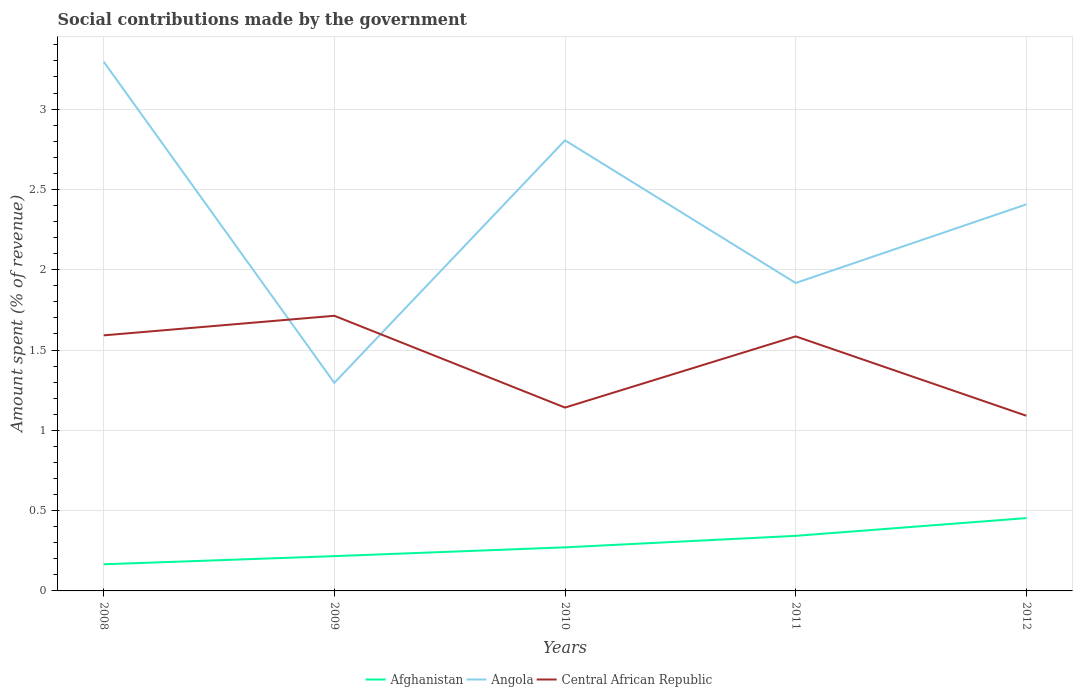How many different coloured lines are there?
Offer a very short reply. 3. Does the line corresponding to Central African Republic intersect with the line corresponding to Afghanistan?
Your response must be concise. No. Is the number of lines equal to the number of legend labels?
Provide a short and direct response. Yes. Across all years, what is the maximum amount spent (in %) on social contributions in Afghanistan?
Give a very brief answer. 0.17. What is the total amount spent (in %) on social contributions in Central African Republic in the graph?
Make the answer very short. 0.05. What is the difference between the highest and the second highest amount spent (in %) on social contributions in Afghanistan?
Provide a succinct answer. 0.29. Is the amount spent (in %) on social contributions in Angola strictly greater than the amount spent (in %) on social contributions in Afghanistan over the years?
Provide a short and direct response. No. What is the difference between two consecutive major ticks on the Y-axis?
Provide a short and direct response. 0.5. Does the graph contain grids?
Provide a short and direct response. Yes. How many legend labels are there?
Make the answer very short. 3. How are the legend labels stacked?
Provide a succinct answer. Horizontal. What is the title of the graph?
Offer a very short reply. Social contributions made by the government. Does "Burkina Faso" appear as one of the legend labels in the graph?
Your answer should be compact. No. What is the label or title of the Y-axis?
Ensure brevity in your answer.  Amount spent (% of revenue). What is the Amount spent (% of revenue) in Afghanistan in 2008?
Give a very brief answer. 0.17. What is the Amount spent (% of revenue) in Angola in 2008?
Your answer should be compact. 3.29. What is the Amount spent (% of revenue) of Central African Republic in 2008?
Make the answer very short. 1.59. What is the Amount spent (% of revenue) of Afghanistan in 2009?
Your answer should be very brief. 0.22. What is the Amount spent (% of revenue) of Angola in 2009?
Offer a very short reply. 1.3. What is the Amount spent (% of revenue) in Central African Republic in 2009?
Offer a terse response. 1.71. What is the Amount spent (% of revenue) of Afghanistan in 2010?
Ensure brevity in your answer.  0.27. What is the Amount spent (% of revenue) in Angola in 2010?
Provide a succinct answer. 2.81. What is the Amount spent (% of revenue) of Central African Republic in 2010?
Provide a short and direct response. 1.14. What is the Amount spent (% of revenue) of Afghanistan in 2011?
Your response must be concise. 0.34. What is the Amount spent (% of revenue) of Angola in 2011?
Your answer should be compact. 1.92. What is the Amount spent (% of revenue) in Central African Republic in 2011?
Keep it short and to the point. 1.58. What is the Amount spent (% of revenue) in Afghanistan in 2012?
Make the answer very short. 0.45. What is the Amount spent (% of revenue) of Angola in 2012?
Give a very brief answer. 2.41. What is the Amount spent (% of revenue) in Central African Republic in 2012?
Your response must be concise. 1.09. Across all years, what is the maximum Amount spent (% of revenue) of Afghanistan?
Offer a terse response. 0.45. Across all years, what is the maximum Amount spent (% of revenue) of Angola?
Ensure brevity in your answer.  3.29. Across all years, what is the maximum Amount spent (% of revenue) of Central African Republic?
Keep it short and to the point. 1.71. Across all years, what is the minimum Amount spent (% of revenue) in Afghanistan?
Your answer should be very brief. 0.17. Across all years, what is the minimum Amount spent (% of revenue) in Angola?
Give a very brief answer. 1.3. Across all years, what is the minimum Amount spent (% of revenue) of Central African Republic?
Keep it short and to the point. 1.09. What is the total Amount spent (% of revenue) of Afghanistan in the graph?
Provide a short and direct response. 1.45. What is the total Amount spent (% of revenue) of Angola in the graph?
Give a very brief answer. 11.72. What is the total Amount spent (% of revenue) of Central African Republic in the graph?
Your response must be concise. 7.12. What is the difference between the Amount spent (% of revenue) of Afghanistan in 2008 and that in 2009?
Keep it short and to the point. -0.05. What is the difference between the Amount spent (% of revenue) of Angola in 2008 and that in 2009?
Your answer should be compact. 2. What is the difference between the Amount spent (% of revenue) in Central African Republic in 2008 and that in 2009?
Your response must be concise. -0.12. What is the difference between the Amount spent (% of revenue) in Afghanistan in 2008 and that in 2010?
Provide a succinct answer. -0.11. What is the difference between the Amount spent (% of revenue) in Angola in 2008 and that in 2010?
Your answer should be very brief. 0.49. What is the difference between the Amount spent (% of revenue) in Central African Republic in 2008 and that in 2010?
Make the answer very short. 0.45. What is the difference between the Amount spent (% of revenue) of Afghanistan in 2008 and that in 2011?
Your answer should be compact. -0.18. What is the difference between the Amount spent (% of revenue) of Angola in 2008 and that in 2011?
Your response must be concise. 1.38. What is the difference between the Amount spent (% of revenue) of Central African Republic in 2008 and that in 2011?
Make the answer very short. 0.01. What is the difference between the Amount spent (% of revenue) of Afghanistan in 2008 and that in 2012?
Your answer should be very brief. -0.29. What is the difference between the Amount spent (% of revenue) in Angola in 2008 and that in 2012?
Your response must be concise. 0.89. What is the difference between the Amount spent (% of revenue) of Central African Republic in 2008 and that in 2012?
Offer a terse response. 0.5. What is the difference between the Amount spent (% of revenue) of Afghanistan in 2009 and that in 2010?
Make the answer very short. -0.05. What is the difference between the Amount spent (% of revenue) in Angola in 2009 and that in 2010?
Provide a succinct answer. -1.51. What is the difference between the Amount spent (% of revenue) in Central African Republic in 2009 and that in 2010?
Offer a very short reply. 0.57. What is the difference between the Amount spent (% of revenue) of Afghanistan in 2009 and that in 2011?
Offer a very short reply. -0.13. What is the difference between the Amount spent (% of revenue) in Angola in 2009 and that in 2011?
Offer a very short reply. -0.62. What is the difference between the Amount spent (% of revenue) in Central African Republic in 2009 and that in 2011?
Offer a terse response. 0.13. What is the difference between the Amount spent (% of revenue) of Afghanistan in 2009 and that in 2012?
Provide a succinct answer. -0.24. What is the difference between the Amount spent (% of revenue) in Angola in 2009 and that in 2012?
Provide a succinct answer. -1.11. What is the difference between the Amount spent (% of revenue) of Central African Republic in 2009 and that in 2012?
Make the answer very short. 0.62. What is the difference between the Amount spent (% of revenue) of Afghanistan in 2010 and that in 2011?
Offer a very short reply. -0.07. What is the difference between the Amount spent (% of revenue) of Angola in 2010 and that in 2011?
Give a very brief answer. 0.89. What is the difference between the Amount spent (% of revenue) in Central African Republic in 2010 and that in 2011?
Your answer should be very brief. -0.44. What is the difference between the Amount spent (% of revenue) of Afghanistan in 2010 and that in 2012?
Your answer should be compact. -0.18. What is the difference between the Amount spent (% of revenue) of Angola in 2010 and that in 2012?
Your answer should be compact. 0.4. What is the difference between the Amount spent (% of revenue) in Central African Republic in 2010 and that in 2012?
Offer a very short reply. 0.05. What is the difference between the Amount spent (% of revenue) of Afghanistan in 2011 and that in 2012?
Offer a terse response. -0.11. What is the difference between the Amount spent (% of revenue) in Angola in 2011 and that in 2012?
Your response must be concise. -0.49. What is the difference between the Amount spent (% of revenue) of Central African Republic in 2011 and that in 2012?
Make the answer very short. 0.49. What is the difference between the Amount spent (% of revenue) of Afghanistan in 2008 and the Amount spent (% of revenue) of Angola in 2009?
Your answer should be very brief. -1.13. What is the difference between the Amount spent (% of revenue) of Afghanistan in 2008 and the Amount spent (% of revenue) of Central African Republic in 2009?
Provide a succinct answer. -1.55. What is the difference between the Amount spent (% of revenue) in Angola in 2008 and the Amount spent (% of revenue) in Central African Republic in 2009?
Give a very brief answer. 1.58. What is the difference between the Amount spent (% of revenue) of Afghanistan in 2008 and the Amount spent (% of revenue) of Angola in 2010?
Provide a succinct answer. -2.64. What is the difference between the Amount spent (% of revenue) in Afghanistan in 2008 and the Amount spent (% of revenue) in Central African Republic in 2010?
Your response must be concise. -0.98. What is the difference between the Amount spent (% of revenue) in Angola in 2008 and the Amount spent (% of revenue) in Central African Republic in 2010?
Give a very brief answer. 2.15. What is the difference between the Amount spent (% of revenue) of Afghanistan in 2008 and the Amount spent (% of revenue) of Angola in 2011?
Your response must be concise. -1.75. What is the difference between the Amount spent (% of revenue) of Afghanistan in 2008 and the Amount spent (% of revenue) of Central African Republic in 2011?
Give a very brief answer. -1.42. What is the difference between the Amount spent (% of revenue) of Angola in 2008 and the Amount spent (% of revenue) of Central African Republic in 2011?
Give a very brief answer. 1.71. What is the difference between the Amount spent (% of revenue) of Afghanistan in 2008 and the Amount spent (% of revenue) of Angola in 2012?
Offer a very short reply. -2.24. What is the difference between the Amount spent (% of revenue) of Afghanistan in 2008 and the Amount spent (% of revenue) of Central African Republic in 2012?
Make the answer very short. -0.92. What is the difference between the Amount spent (% of revenue) in Angola in 2008 and the Amount spent (% of revenue) in Central African Republic in 2012?
Ensure brevity in your answer.  2.2. What is the difference between the Amount spent (% of revenue) of Afghanistan in 2009 and the Amount spent (% of revenue) of Angola in 2010?
Your answer should be compact. -2.59. What is the difference between the Amount spent (% of revenue) in Afghanistan in 2009 and the Amount spent (% of revenue) in Central African Republic in 2010?
Your answer should be compact. -0.93. What is the difference between the Amount spent (% of revenue) in Angola in 2009 and the Amount spent (% of revenue) in Central African Republic in 2010?
Offer a very short reply. 0.15. What is the difference between the Amount spent (% of revenue) in Afghanistan in 2009 and the Amount spent (% of revenue) in Angola in 2011?
Your answer should be compact. -1.7. What is the difference between the Amount spent (% of revenue) in Afghanistan in 2009 and the Amount spent (% of revenue) in Central African Republic in 2011?
Ensure brevity in your answer.  -1.37. What is the difference between the Amount spent (% of revenue) of Angola in 2009 and the Amount spent (% of revenue) of Central African Republic in 2011?
Give a very brief answer. -0.29. What is the difference between the Amount spent (% of revenue) in Afghanistan in 2009 and the Amount spent (% of revenue) in Angola in 2012?
Offer a terse response. -2.19. What is the difference between the Amount spent (% of revenue) in Afghanistan in 2009 and the Amount spent (% of revenue) in Central African Republic in 2012?
Offer a terse response. -0.87. What is the difference between the Amount spent (% of revenue) in Angola in 2009 and the Amount spent (% of revenue) in Central African Republic in 2012?
Ensure brevity in your answer.  0.2. What is the difference between the Amount spent (% of revenue) of Afghanistan in 2010 and the Amount spent (% of revenue) of Angola in 2011?
Make the answer very short. -1.65. What is the difference between the Amount spent (% of revenue) in Afghanistan in 2010 and the Amount spent (% of revenue) in Central African Republic in 2011?
Offer a terse response. -1.31. What is the difference between the Amount spent (% of revenue) of Angola in 2010 and the Amount spent (% of revenue) of Central African Republic in 2011?
Ensure brevity in your answer.  1.22. What is the difference between the Amount spent (% of revenue) in Afghanistan in 2010 and the Amount spent (% of revenue) in Angola in 2012?
Your answer should be very brief. -2.14. What is the difference between the Amount spent (% of revenue) in Afghanistan in 2010 and the Amount spent (% of revenue) in Central African Republic in 2012?
Give a very brief answer. -0.82. What is the difference between the Amount spent (% of revenue) in Angola in 2010 and the Amount spent (% of revenue) in Central African Republic in 2012?
Give a very brief answer. 1.71. What is the difference between the Amount spent (% of revenue) in Afghanistan in 2011 and the Amount spent (% of revenue) in Angola in 2012?
Give a very brief answer. -2.06. What is the difference between the Amount spent (% of revenue) of Afghanistan in 2011 and the Amount spent (% of revenue) of Central African Republic in 2012?
Provide a succinct answer. -0.75. What is the difference between the Amount spent (% of revenue) of Angola in 2011 and the Amount spent (% of revenue) of Central African Republic in 2012?
Ensure brevity in your answer.  0.83. What is the average Amount spent (% of revenue) in Afghanistan per year?
Give a very brief answer. 0.29. What is the average Amount spent (% of revenue) of Angola per year?
Offer a terse response. 2.34. What is the average Amount spent (% of revenue) of Central African Republic per year?
Provide a succinct answer. 1.42. In the year 2008, what is the difference between the Amount spent (% of revenue) of Afghanistan and Amount spent (% of revenue) of Angola?
Provide a succinct answer. -3.13. In the year 2008, what is the difference between the Amount spent (% of revenue) of Afghanistan and Amount spent (% of revenue) of Central African Republic?
Your response must be concise. -1.43. In the year 2008, what is the difference between the Amount spent (% of revenue) in Angola and Amount spent (% of revenue) in Central African Republic?
Make the answer very short. 1.7. In the year 2009, what is the difference between the Amount spent (% of revenue) of Afghanistan and Amount spent (% of revenue) of Angola?
Offer a terse response. -1.08. In the year 2009, what is the difference between the Amount spent (% of revenue) of Afghanistan and Amount spent (% of revenue) of Central African Republic?
Provide a succinct answer. -1.5. In the year 2009, what is the difference between the Amount spent (% of revenue) of Angola and Amount spent (% of revenue) of Central African Republic?
Offer a very short reply. -0.42. In the year 2010, what is the difference between the Amount spent (% of revenue) in Afghanistan and Amount spent (% of revenue) in Angola?
Your answer should be very brief. -2.53. In the year 2010, what is the difference between the Amount spent (% of revenue) of Afghanistan and Amount spent (% of revenue) of Central African Republic?
Make the answer very short. -0.87. In the year 2010, what is the difference between the Amount spent (% of revenue) of Angola and Amount spent (% of revenue) of Central African Republic?
Offer a very short reply. 1.66. In the year 2011, what is the difference between the Amount spent (% of revenue) in Afghanistan and Amount spent (% of revenue) in Angola?
Keep it short and to the point. -1.57. In the year 2011, what is the difference between the Amount spent (% of revenue) of Afghanistan and Amount spent (% of revenue) of Central African Republic?
Ensure brevity in your answer.  -1.24. In the year 2011, what is the difference between the Amount spent (% of revenue) of Angola and Amount spent (% of revenue) of Central African Republic?
Provide a short and direct response. 0.33. In the year 2012, what is the difference between the Amount spent (% of revenue) in Afghanistan and Amount spent (% of revenue) in Angola?
Offer a terse response. -1.95. In the year 2012, what is the difference between the Amount spent (% of revenue) of Afghanistan and Amount spent (% of revenue) of Central African Republic?
Your answer should be very brief. -0.64. In the year 2012, what is the difference between the Amount spent (% of revenue) in Angola and Amount spent (% of revenue) in Central African Republic?
Provide a succinct answer. 1.32. What is the ratio of the Amount spent (% of revenue) in Afghanistan in 2008 to that in 2009?
Offer a very short reply. 0.77. What is the ratio of the Amount spent (% of revenue) in Angola in 2008 to that in 2009?
Keep it short and to the point. 2.54. What is the ratio of the Amount spent (% of revenue) of Central African Republic in 2008 to that in 2009?
Your response must be concise. 0.93. What is the ratio of the Amount spent (% of revenue) in Afghanistan in 2008 to that in 2010?
Make the answer very short. 0.61. What is the ratio of the Amount spent (% of revenue) in Angola in 2008 to that in 2010?
Your answer should be very brief. 1.17. What is the ratio of the Amount spent (% of revenue) in Central African Republic in 2008 to that in 2010?
Keep it short and to the point. 1.39. What is the ratio of the Amount spent (% of revenue) in Afghanistan in 2008 to that in 2011?
Your answer should be compact. 0.48. What is the ratio of the Amount spent (% of revenue) of Angola in 2008 to that in 2011?
Your response must be concise. 1.72. What is the ratio of the Amount spent (% of revenue) of Central African Republic in 2008 to that in 2011?
Your answer should be compact. 1. What is the ratio of the Amount spent (% of revenue) of Afghanistan in 2008 to that in 2012?
Your answer should be very brief. 0.37. What is the ratio of the Amount spent (% of revenue) of Angola in 2008 to that in 2012?
Give a very brief answer. 1.37. What is the ratio of the Amount spent (% of revenue) of Central African Republic in 2008 to that in 2012?
Your answer should be compact. 1.46. What is the ratio of the Amount spent (% of revenue) of Afghanistan in 2009 to that in 2010?
Offer a terse response. 0.8. What is the ratio of the Amount spent (% of revenue) in Angola in 2009 to that in 2010?
Ensure brevity in your answer.  0.46. What is the ratio of the Amount spent (% of revenue) of Central African Republic in 2009 to that in 2010?
Keep it short and to the point. 1.5. What is the ratio of the Amount spent (% of revenue) of Afghanistan in 2009 to that in 2011?
Provide a short and direct response. 0.63. What is the ratio of the Amount spent (% of revenue) of Angola in 2009 to that in 2011?
Your answer should be very brief. 0.68. What is the ratio of the Amount spent (% of revenue) of Central African Republic in 2009 to that in 2011?
Offer a terse response. 1.08. What is the ratio of the Amount spent (% of revenue) of Afghanistan in 2009 to that in 2012?
Provide a short and direct response. 0.48. What is the ratio of the Amount spent (% of revenue) of Angola in 2009 to that in 2012?
Ensure brevity in your answer.  0.54. What is the ratio of the Amount spent (% of revenue) in Central African Republic in 2009 to that in 2012?
Provide a short and direct response. 1.57. What is the ratio of the Amount spent (% of revenue) in Afghanistan in 2010 to that in 2011?
Offer a very short reply. 0.79. What is the ratio of the Amount spent (% of revenue) in Angola in 2010 to that in 2011?
Provide a short and direct response. 1.46. What is the ratio of the Amount spent (% of revenue) of Central African Republic in 2010 to that in 2011?
Make the answer very short. 0.72. What is the ratio of the Amount spent (% of revenue) of Afghanistan in 2010 to that in 2012?
Offer a very short reply. 0.6. What is the ratio of the Amount spent (% of revenue) of Angola in 2010 to that in 2012?
Your response must be concise. 1.17. What is the ratio of the Amount spent (% of revenue) in Central African Republic in 2010 to that in 2012?
Offer a very short reply. 1.05. What is the ratio of the Amount spent (% of revenue) in Afghanistan in 2011 to that in 2012?
Give a very brief answer. 0.76. What is the ratio of the Amount spent (% of revenue) in Angola in 2011 to that in 2012?
Offer a very short reply. 0.8. What is the ratio of the Amount spent (% of revenue) of Central African Republic in 2011 to that in 2012?
Provide a succinct answer. 1.45. What is the difference between the highest and the second highest Amount spent (% of revenue) of Afghanistan?
Your answer should be compact. 0.11. What is the difference between the highest and the second highest Amount spent (% of revenue) in Angola?
Your answer should be very brief. 0.49. What is the difference between the highest and the second highest Amount spent (% of revenue) in Central African Republic?
Your response must be concise. 0.12. What is the difference between the highest and the lowest Amount spent (% of revenue) in Afghanistan?
Your answer should be very brief. 0.29. What is the difference between the highest and the lowest Amount spent (% of revenue) of Angola?
Offer a very short reply. 2. What is the difference between the highest and the lowest Amount spent (% of revenue) of Central African Republic?
Ensure brevity in your answer.  0.62. 